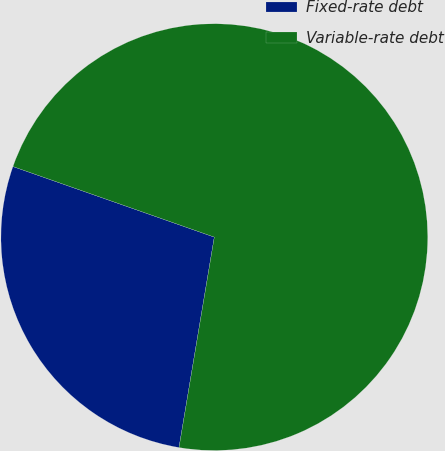<chart> <loc_0><loc_0><loc_500><loc_500><pie_chart><fcel>Fixed-rate debt<fcel>Variable-rate debt<nl><fcel>27.72%<fcel>72.28%<nl></chart> 